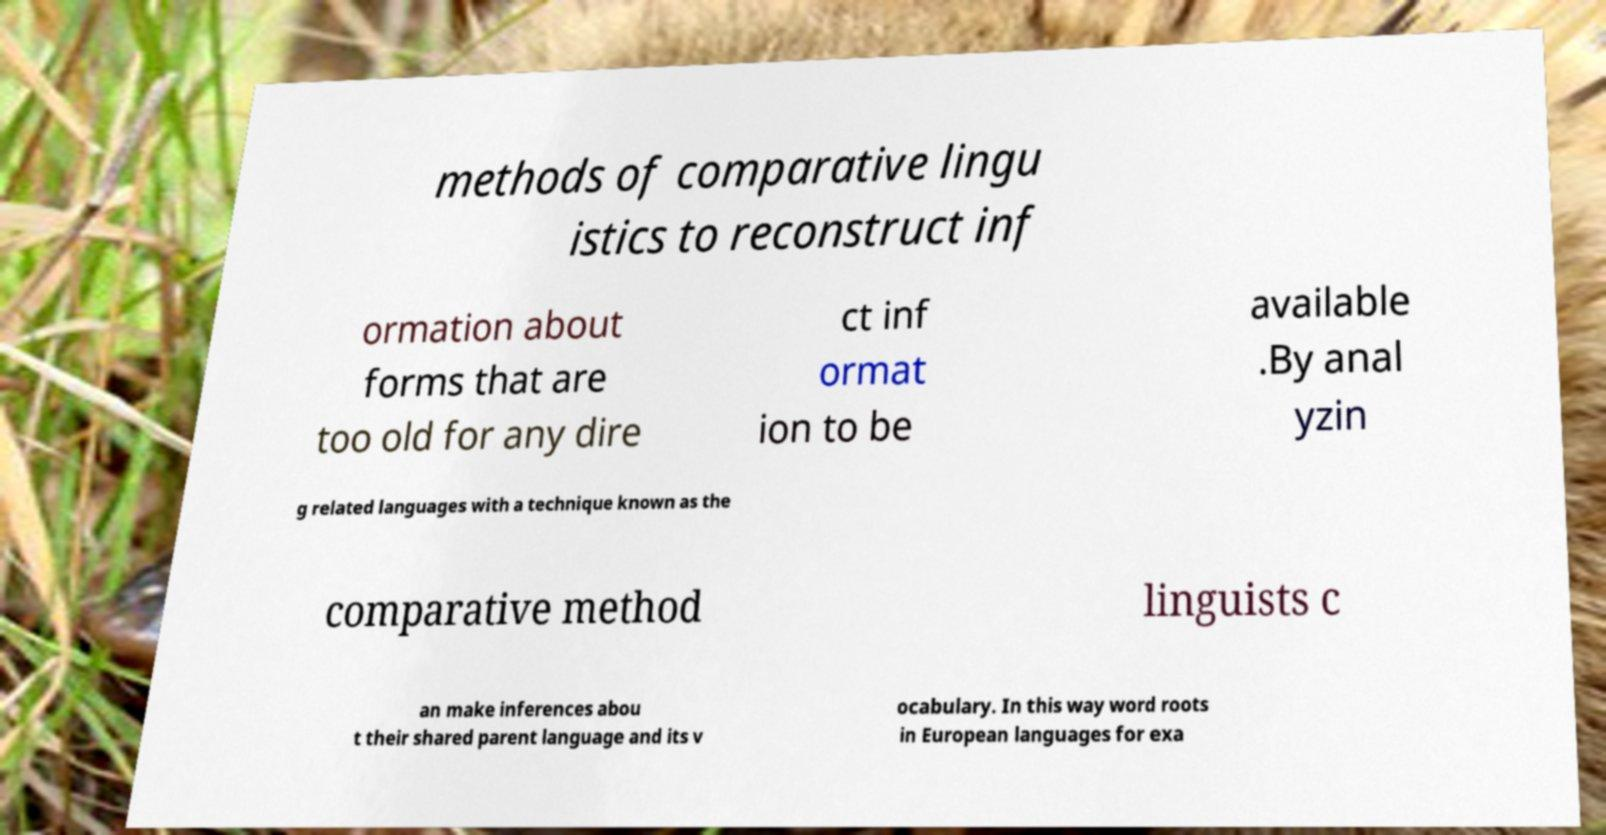Could you extract and type out the text from this image? methods of comparative lingu istics to reconstruct inf ormation about forms that are too old for any dire ct inf ormat ion to be available .By anal yzin g related languages with a technique known as the comparative method linguists c an make inferences abou t their shared parent language and its v ocabulary. In this way word roots in European languages for exa 